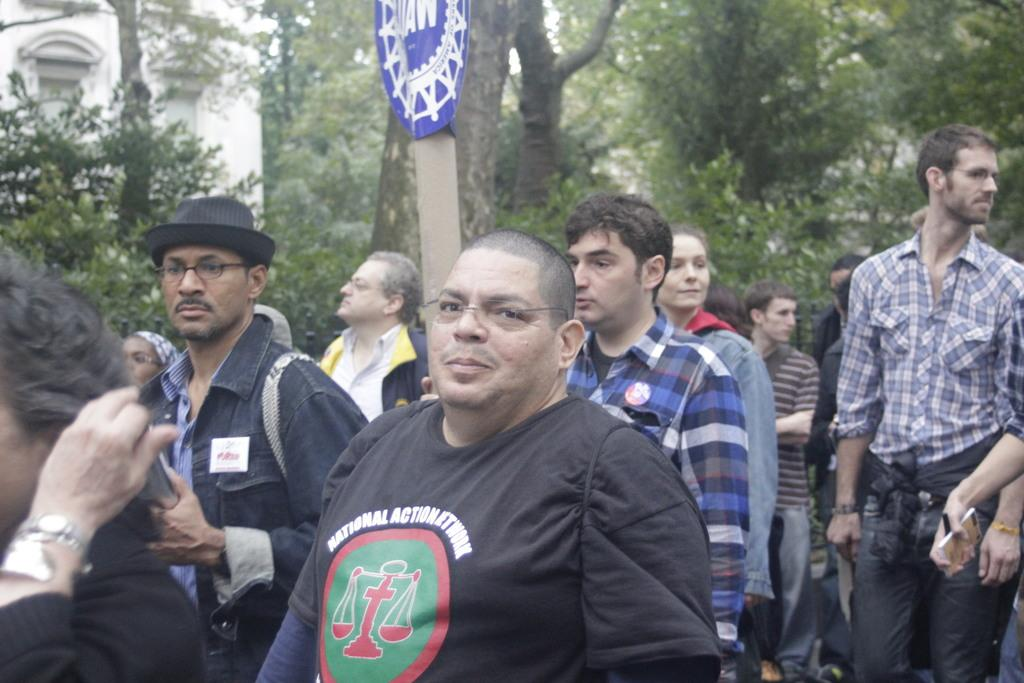Provide a one-sentence caption for the provided image. A man wearing a National Action Network T-Shirt gathers with others at a rally. 